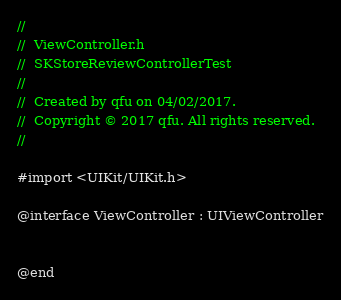Convert code to text. <code><loc_0><loc_0><loc_500><loc_500><_C_>//
//  ViewController.h
//  SKStoreReviewControllerTest
//
//  Created by qfu on 04/02/2017.
//  Copyright © 2017 qfu. All rights reserved.
//

#import <UIKit/UIKit.h>

@interface ViewController : UIViewController


@end

</code> 